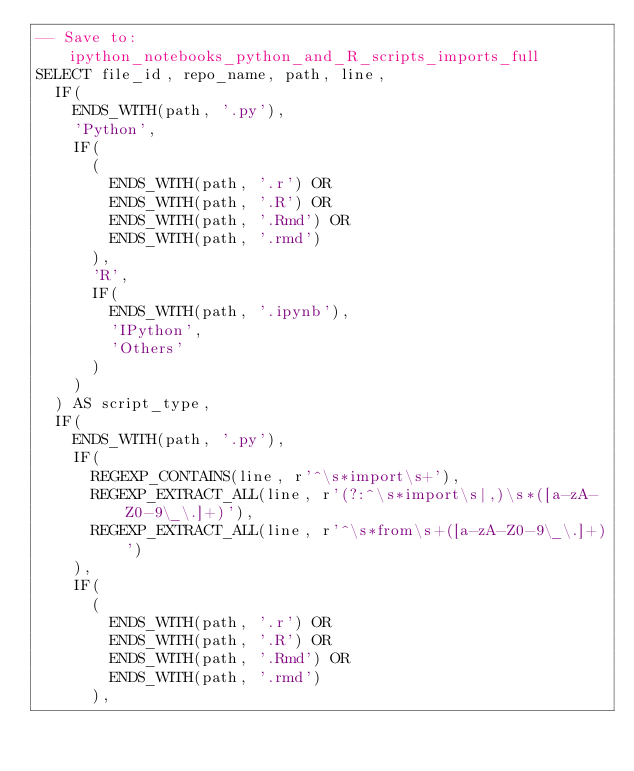Convert code to text. <code><loc_0><loc_0><loc_500><loc_500><_SQL_>-- Save to: ipython_notebooks_python_and_R_scripts_imports_full
SELECT file_id, repo_name, path, line,
  IF(
    ENDS_WITH(path, '.py'),
    'Python',
    IF(
      (
        ENDS_WITH(path, '.r') OR
        ENDS_WITH(path, '.R') OR
        ENDS_WITH(path, '.Rmd') OR
        ENDS_WITH(path, '.rmd')
      ),
      'R',
      IF(
        ENDS_WITH(path, '.ipynb'),
        'IPython',
        'Others'
      )
    )
  ) AS script_type,
  IF(
    ENDS_WITH(path, '.py'),
    IF(
      REGEXP_CONTAINS(line, r'^\s*import\s+'),
      REGEXP_EXTRACT_ALL(line, r'(?:^\s*import\s|,)\s*([a-zA-Z0-9\_\.]+)'),
      REGEXP_EXTRACT_ALL(line, r'^\s*from\s+([a-zA-Z0-9\_\.]+)')
    ),
    IF(
      (
        ENDS_WITH(path, '.r') OR
        ENDS_WITH(path, '.R') OR
        ENDS_WITH(path, '.Rmd') OR
        ENDS_WITH(path, '.rmd')
      ),</code> 